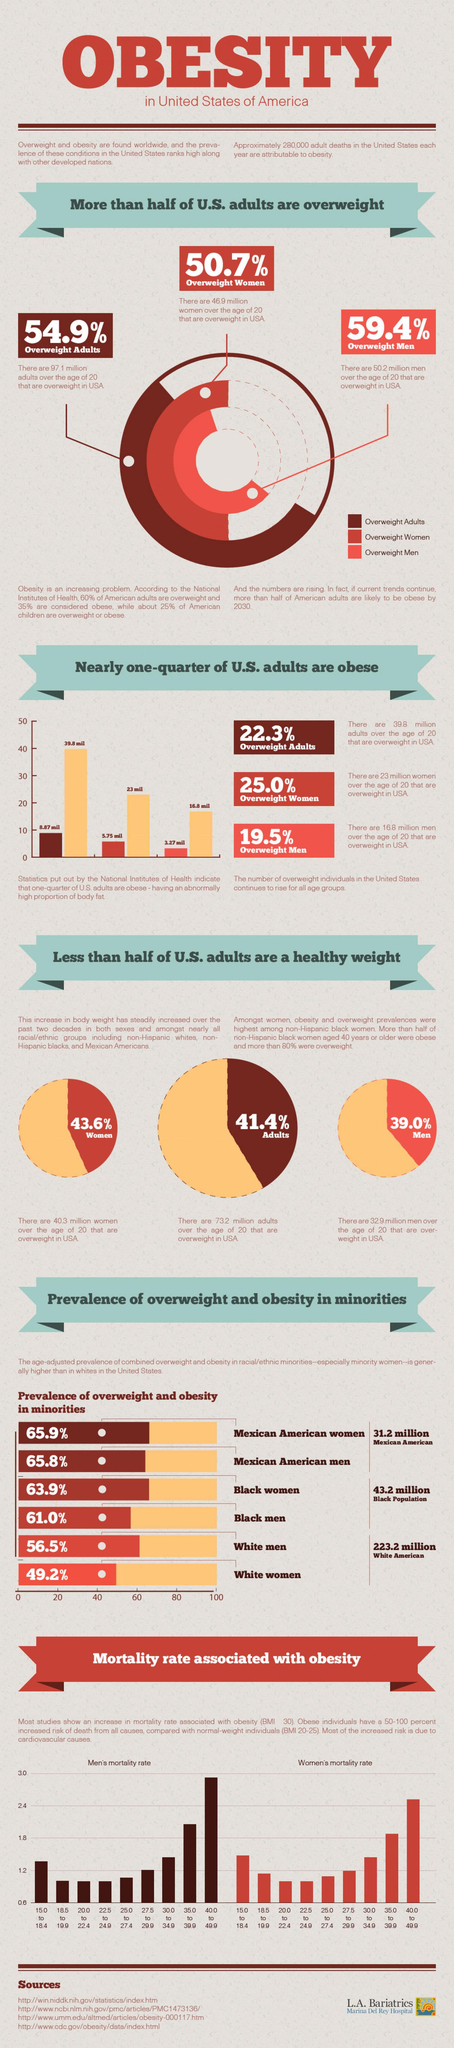Mention a couple of crucial points in this snapshot. According to the pie chart, men have more overweight adults than women. Men have a higher mortality rate associated with obesity compared to women. The second largest percentage of overweight and obesity among minority group genders belongs to Black women. 